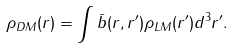<formula> <loc_0><loc_0><loc_500><loc_500>\rho _ { D M } ( r ) = \int \bar { b } ( r , r ^ { \prime } ) \rho _ { L M } ( r ^ { \prime } ) d ^ { 3 } r ^ { \prime } .</formula> 